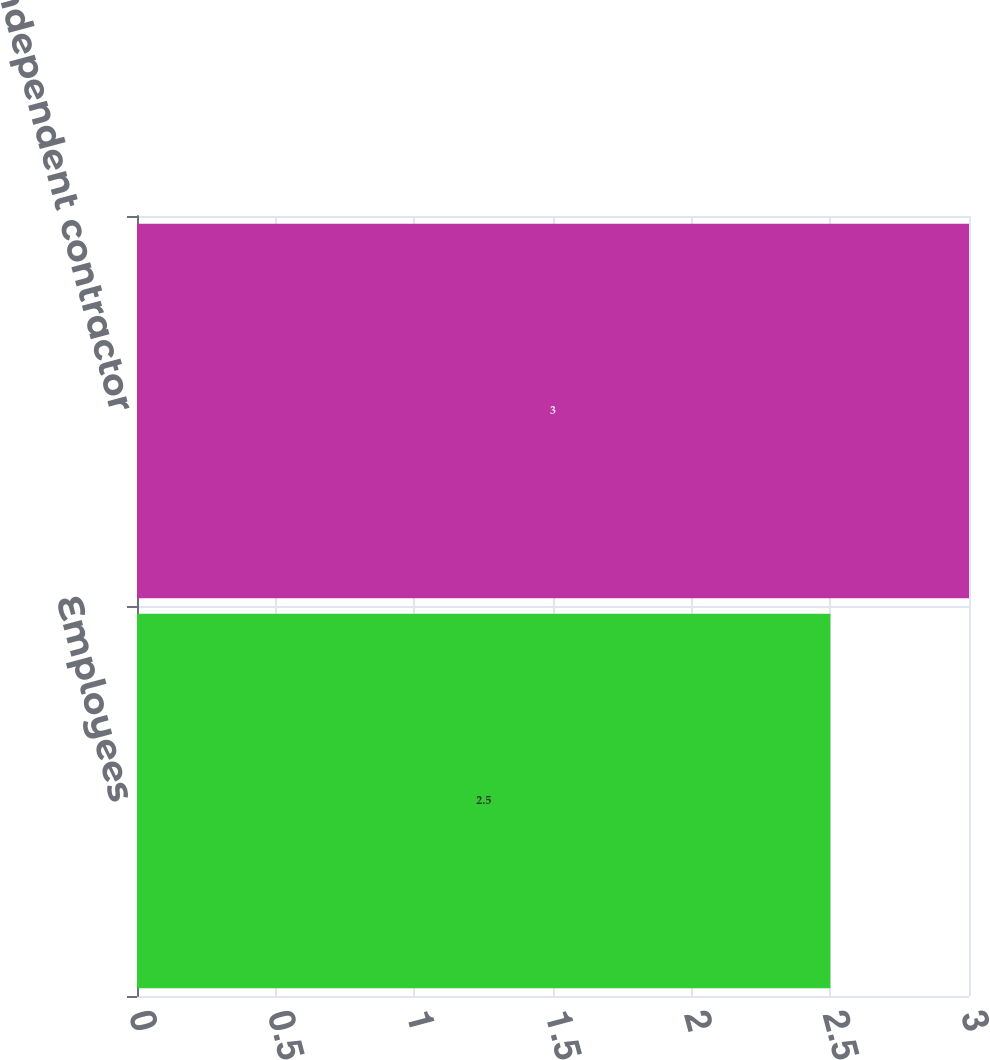<chart> <loc_0><loc_0><loc_500><loc_500><bar_chart><fcel>Employees<fcel>Independent contractor<nl><fcel>2.5<fcel>3<nl></chart> 